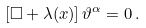Convert formula to latex. <formula><loc_0><loc_0><loc_500><loc_500>\left [ \square + \lambda ( x ) \right ] \vartheta ^ { \alpha } = 0 \, .</formula> 